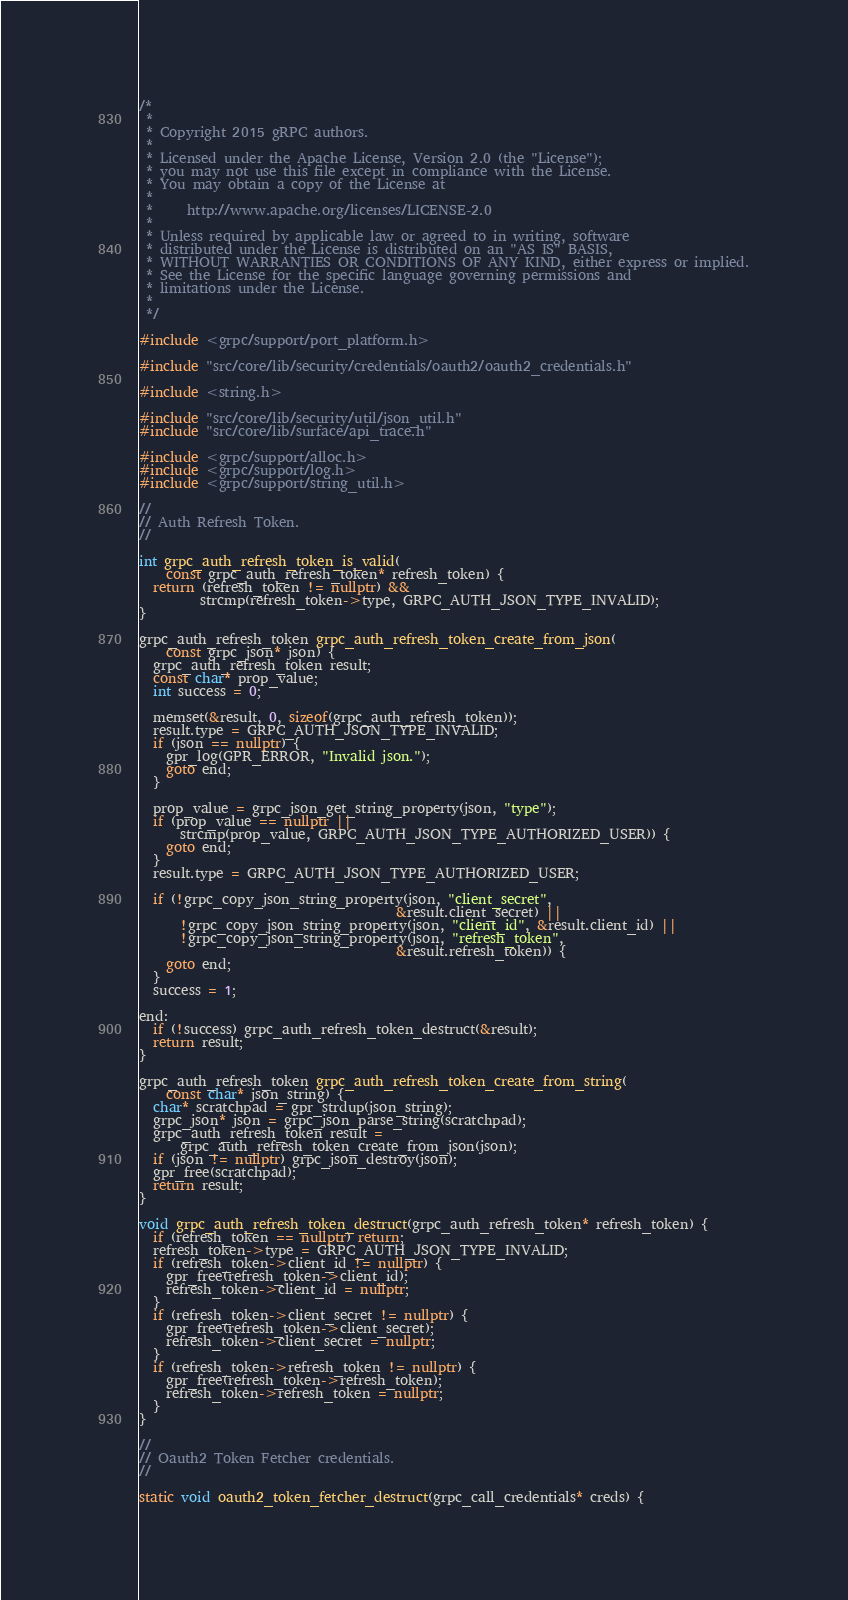<code> <loc_0><loc_0><loc_500><loc_500><_C++_>/*
 *
 * Copyright 2015 gRPC authors.
 *
 * Licensed under the Apache License, Version 2.0 (the "License");
 * you may not use this file except in compliance with the License.
 * You may obtain a copy of the License at
 *
 *     http://www.apache.org/licenses/LICENSE-2.0
 *
 * Unless required by applicable law or agreed to in writing, software
 * distributed under the License is distributed on an "AS IS" BASIS,
 * WITHOUT WARRANTIES OR CONDITIONS OF ANY KIND, either express or implied.
 * See the License for the specific language governing permissions and
 * limitations under the License.
 *
 */

#include <grpc/support/port_platform.h>

#include "src/core/lib/security/credentials/oauth2/oauth2_credentials.h"

#include <string.h>

#include "src/core/lib/security/util/json_util.h"
#include "src/core/lib/surface/api_trace.h"

#include <grpc/support/alloc.h>
#include <grpc/support/log.h>
#include <grpc/support/string_util.h>

//
// Auth Refresh Token.
//

int grpc_auth_refresh_token_is_valid(
    const grpc_auth_refresh_token* refresh_token) {
  return (refresh_token != nullptr) &&
         strcmp(refresh_token->type, GRPC_AUTH_JSON_TYPE_INVALID);
}

grpc_auth_refresh_token grpc_auth_refresh_token_create_from_json(
    const grpc_json* json) {
  grpc_auth_refresh_token result;
  const char* prop_value;
  int success = 0;

  memset(&result, 0, sizeof(grpc_auth_refresh_token));
  result.type = GRPC_AUTH_JSON_TYPE_INVALID;
  if (json == nullptr) {
    gpr_log(GPR_ERROR, "Invalid json.");
    goto end;
  }

  prop_value = grpc_json_get_string_property(json, "type");
  if (prop_value == nullptr ||
      strcmp(prop_value, GRPC_AUTH_JSON_TYPE_AUTHORIZED_USER)) {
    goto end;
  }
  result.type = GRPC_AUTH_JSON_TYPE_AUTHORIZED_USER;

  if (!grpc_copy_json_string_property(json, "client_secret",
                                      &result.client_secret) ||
      !grpc_copy_json_string_property(json, "client_id", &result.client_id) ||
      !grpc_copy_json_string_property(json, "refresh_token",
                                      &result.refresh_token)) {
    goto end;
  }
  success = 1;

end:
  if (!success) grpc_auth_refresh_token_destruct(&result);
  return result;
}

grpc_auth_refresh_token grpc_auth_refresh_token_create_from_string(
    const char* json_string) {
  char* scratchpad = gpr_strdup(json_string);
  grpc_json* json = grpc_json_parse_string(scratchpad);
  grpc_auth_refresh_token result =
      grpc_auth_refresh_token_create_from_json(json);
  if (json != nullptr) grpc_json_destroy(json);
  gpr_free(scratchpad);
  return result;
}

void grpc_auth_refresh_token_destruct(grpc_auth_refresh_token* refresh_token) {
  if (refresh_token == nullptr) return;
  refresh_token->type = GRPC_AUTH_JSON_TYPE_INVALID;
  if (refresh_token->client_id != nullptr) {
    gpr_free(refresh_token->client_id);
    refresh_token->client_id = nullptr;
  }
  if (refresh_token->client_secret != nullptr) {
    gpr_free(refresh_token->client_secret);
    refresh_token->client_secret = nullptr;
  }
  if (refresh_token->refresh_token != nullptr) {
    gpr_free(refresh_token->refresh_token);
    refresh_token->refresh_token = nullptr;
  }
}

//
// Oauth2 Token Fetcher credentials.
//

static void oauth2_token_fetcher_destruct(grpc_call_credentials* creds) {</code> 